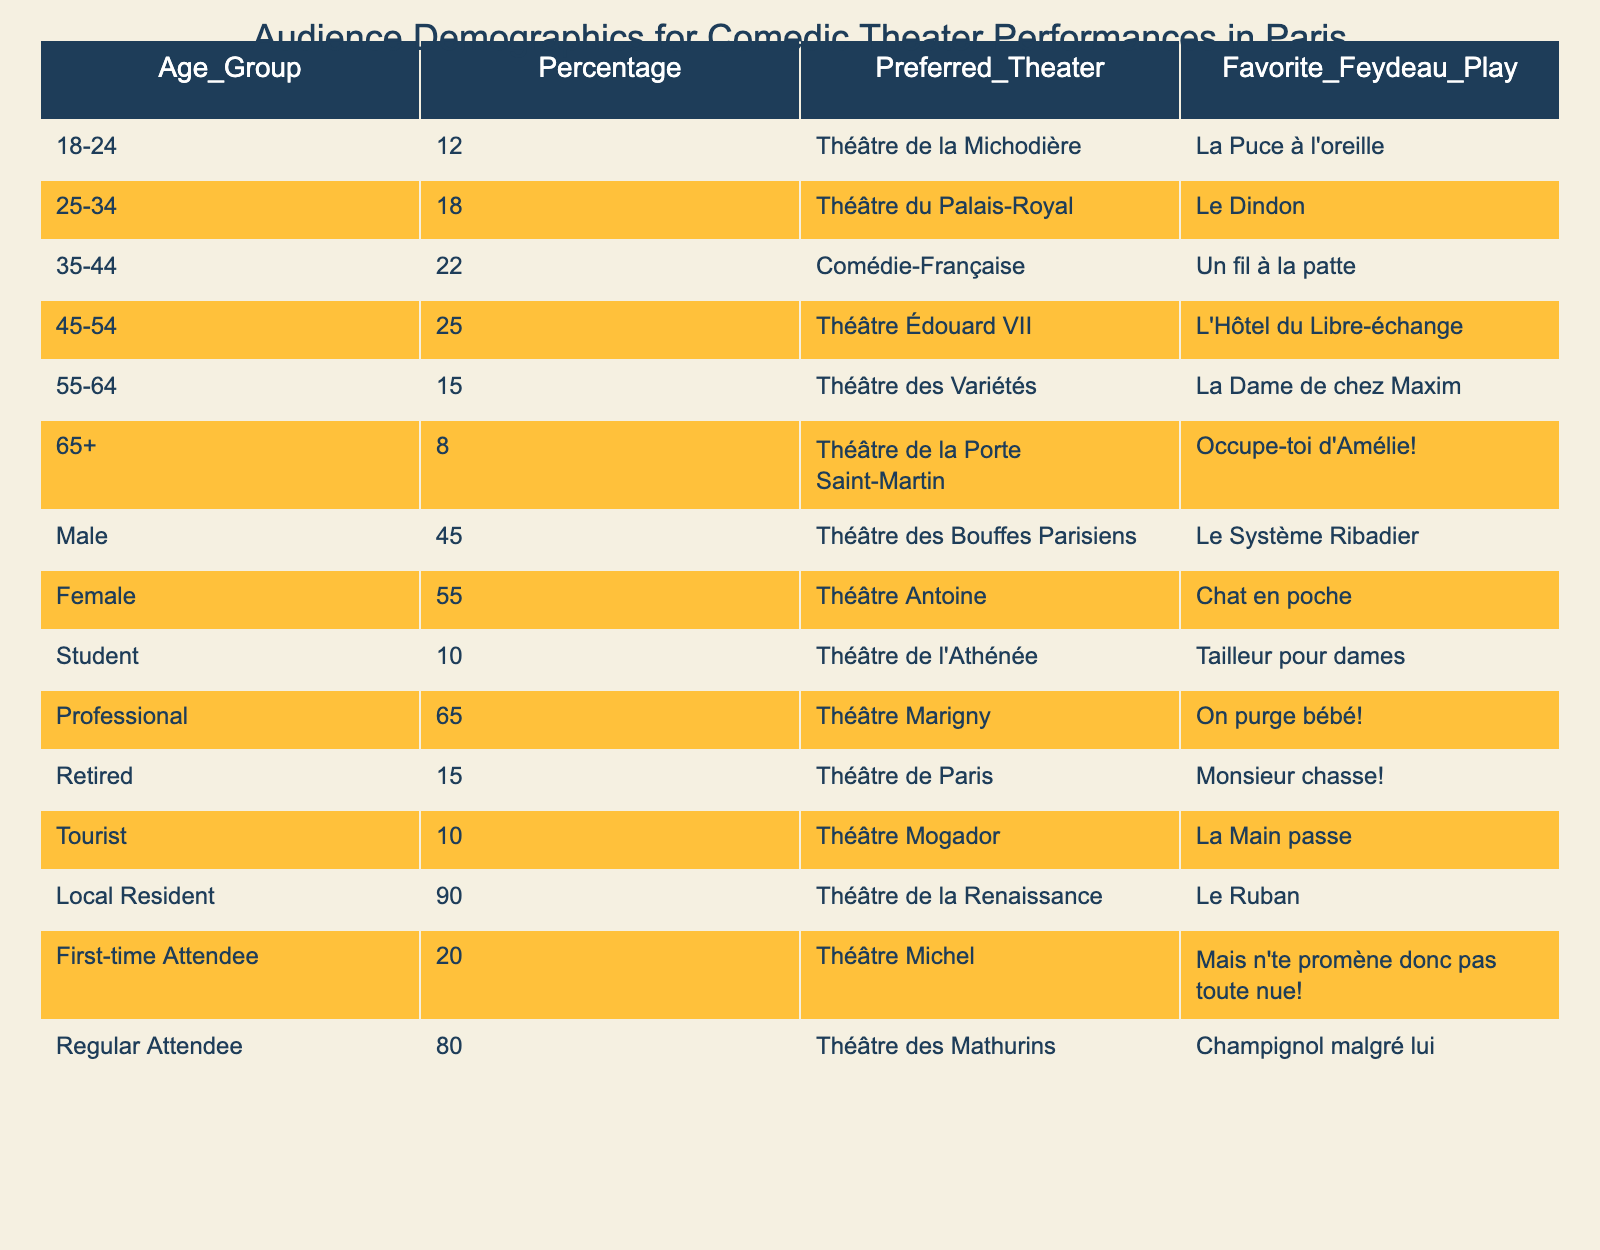What age group has the highest percentage of audience members? The table indicates the percentage of audience members in each age group. The 45-54 age group has the highest percentage at 25% compared to the other groups.
Answer: 45-54 Which theater is most preferred by local residents? From the data, local residents prefer the Théâtre de la Renaissance. The percentage for local residents is 90%, which is the highest among all demographics.
Answer: Théâtre de la Renaissance What percentage of the audience are students? The percentage of students in the audience is listed as 10% in the table.
Answer: 10% What is the age group with the least audience representation? The age group of 65 and older has the least representation, with only 8% of the audience.
Answer: 65+ If you combine the percentages of tourists and students, what is the total? The percentage of tourists is 10% and the percentage of students is also 10%. When combined, they total 20%.
Answer: 20% Is there a favorite Feydeau play for the professional demographic? Yes, the favorite play listed for the professional demographic is "On purge bébé!" according to the table.
Answer: Yes What is the favorite Feydeau play for the retired audience? The table shows that retired audiences favor "Monsieur chasse!"
Answer: Monsieur chasse! Which group has a higher percentage: males or females? Males represent 45% of the audience while females represent 55%, so females have a higher percentage.
Answer: Females If you add the percentages of first-time attendees and tourists, what is the result? First-time attendees constitute 20% while tourists are 10%. Adding these gives a total of 30%.
Answer: 30% What is the preferred theater for audience members aged 55-64? For the age group 55-64, the preferred theater is the Théâtre des Variétés.
Answer: Théâtre des Variétés 